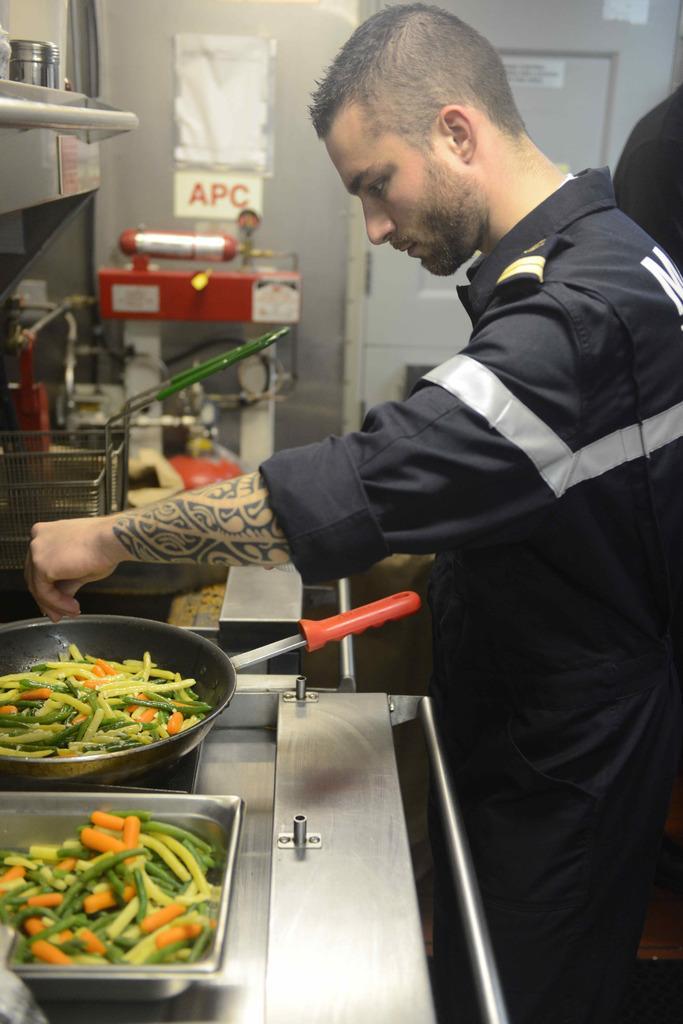How would you summarize this image in a sentence or two? In this image, on the left side there is a stove, on that stove there are pans, in that pans there are vegetables, beside the stove there is a person standing, in the background there are machines and a wall. 